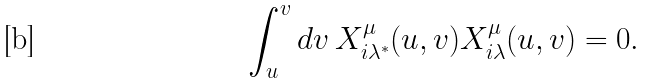Convert formula to latex. <formula><loc_0><loc_0><loc_500><loc_500>\int _ { u } ^ { v } d v \, X _ { i \lambda ^ { \ast } } ^ { \mu } ( u , v ) X _ { i \lambda } ^ { \mu } ( u , v ) = 0 .</formula> 